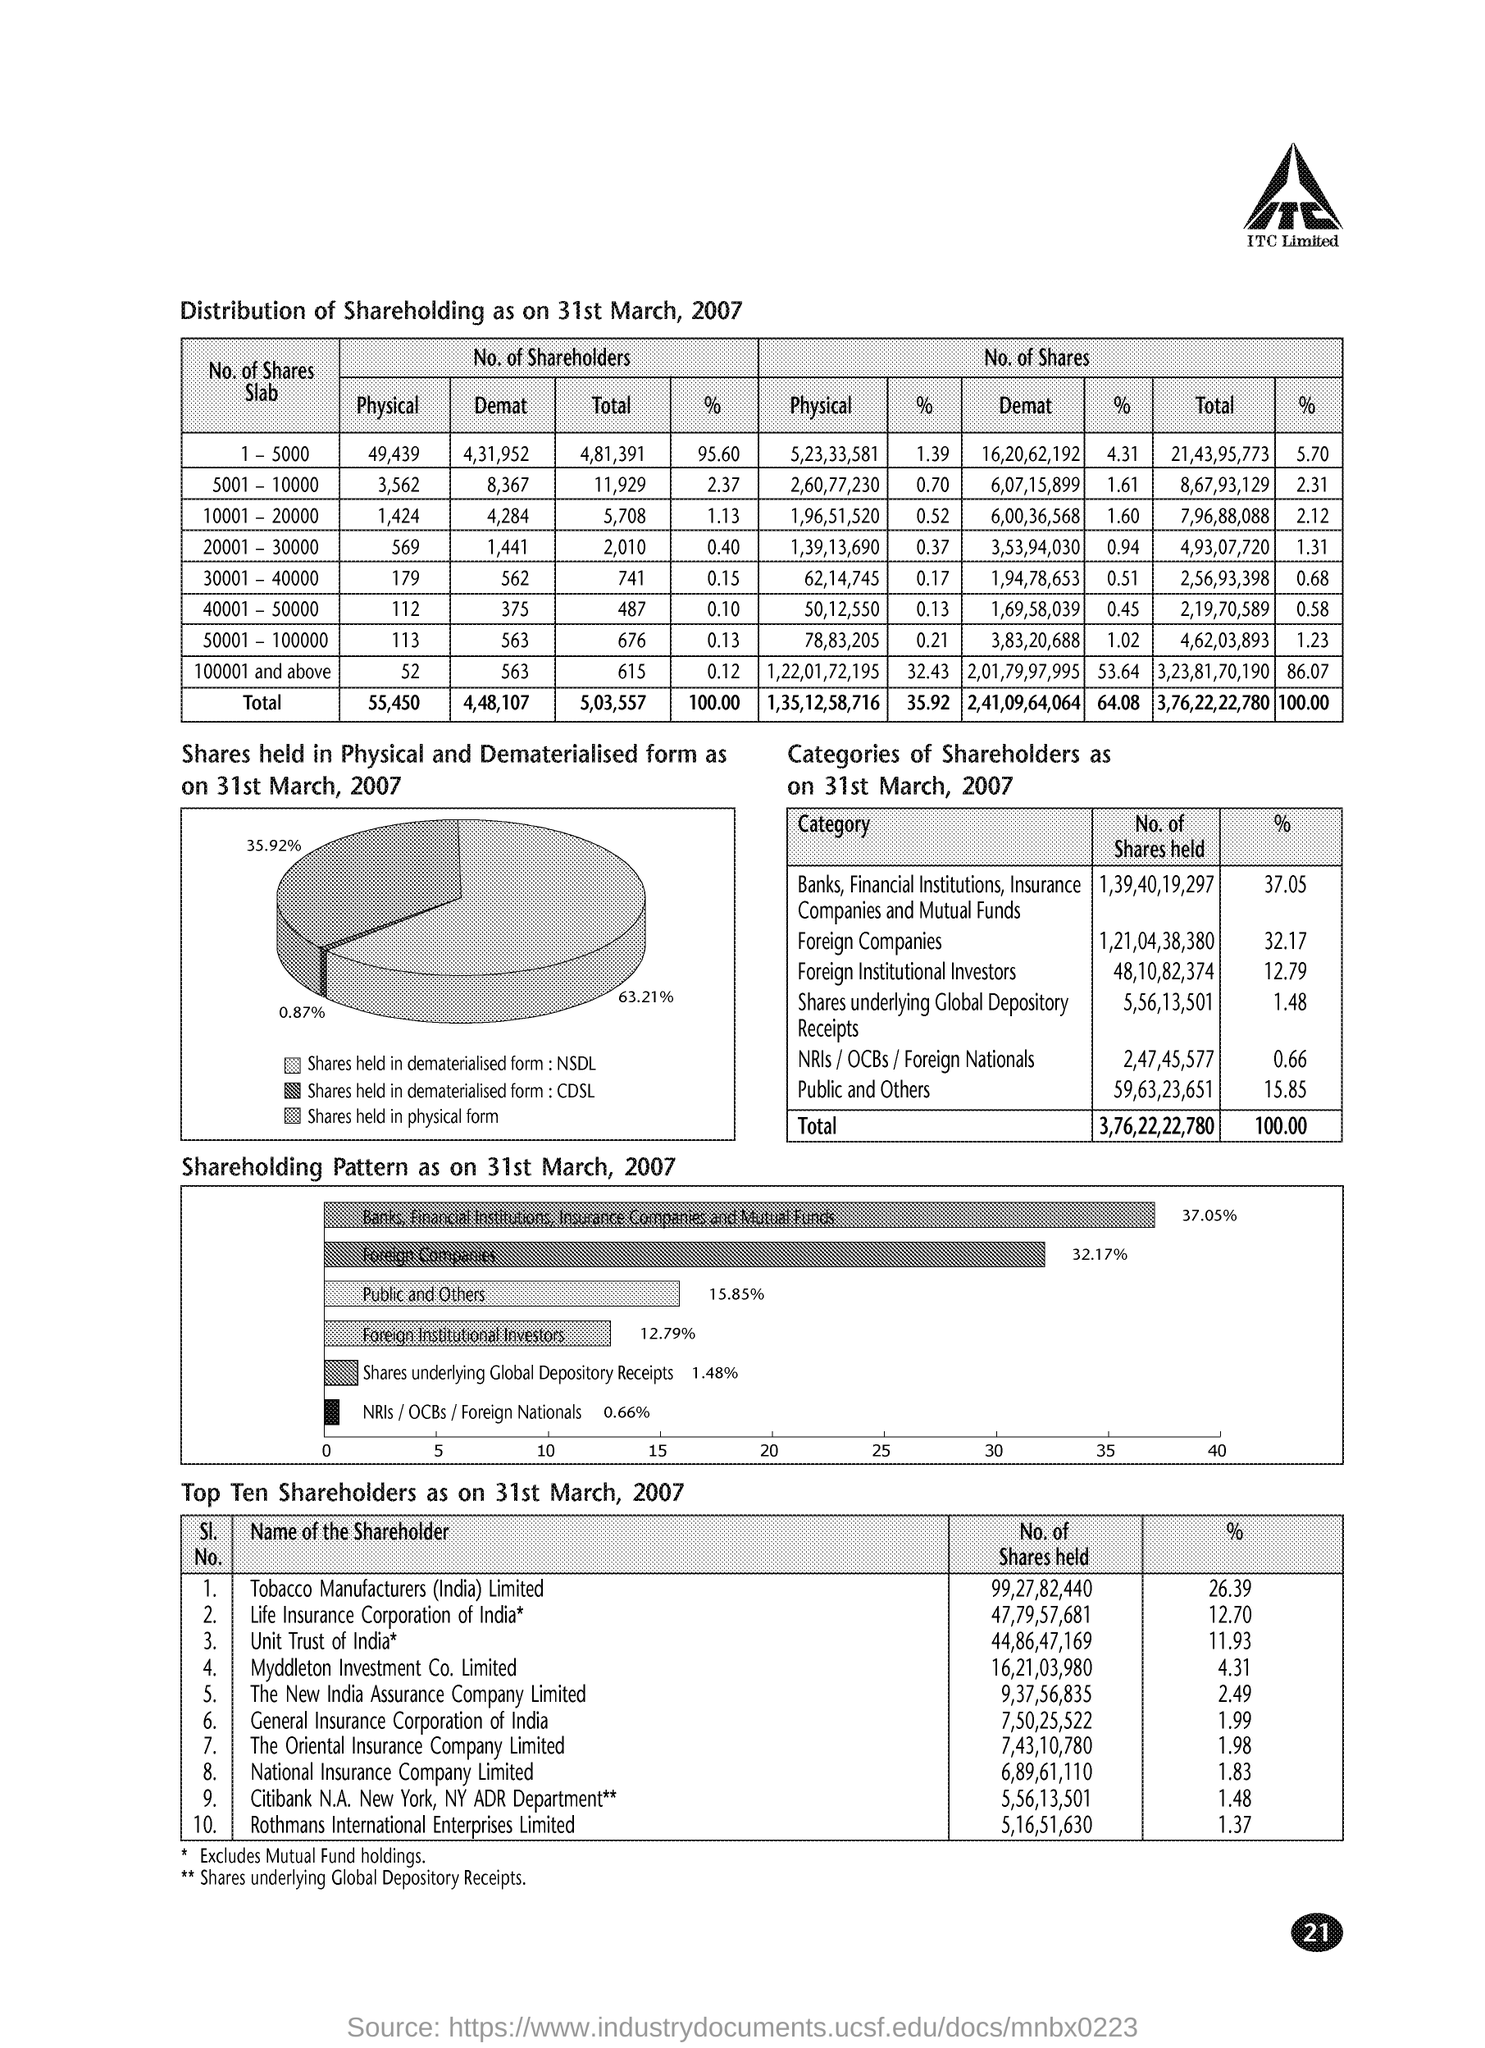Could you provide a breakdown of the shareholding pattern by category? According to the image, the shareholding pattern as on 31st March, 2007 is categorized as follows: Banks, Financial Institutions, Insurance Companies, and Mutual Funds hold 37.05%, Foreign Companies possess 32.17%, Foreign Institutional Investors account for 12.79%, Shares underlying Global Depository Receipts are at 1.48%, NRIs/OCBs/Foreign Nationals have 0.66%, and Public and Others make up 15.85% of the total shares. 